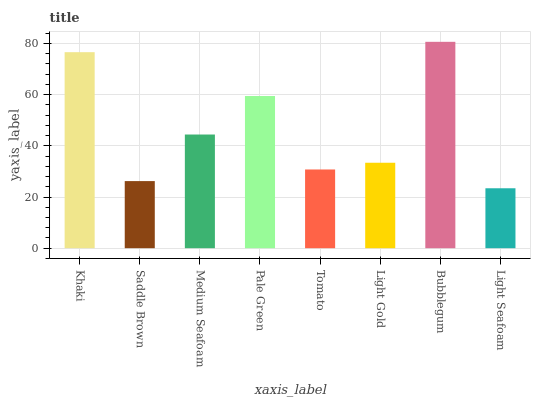Is Light Seafoam the minimum?
Answer yes or no. Yes. Is Bubblegum the maximum?
Answer yes or no. Yes. Is Saddle Brown the minimum?
Answer yes or no. No. Is Saddle Brown the maximum?
Answer yes or no. No. Is Khaki greater than Saddle Brown?
Answer yes or no. Yes. Is Saddle Brown less than Khaki?
Answer yes or no. Yes. Is Saddle Brown greater than Khaki?
Answer yes or no. No. Is Khaki less than Saddle Brown?
Answer yes or no. No. Is Medium Seafoam the high median?
Answer yes or no. Yes. Is Light Gold the low median?
Answer yes or no. Yes. Is Bubblegum the high median?
Answer yes or no. No. Is Pale Green the low median?
Answer yes or no. No. 